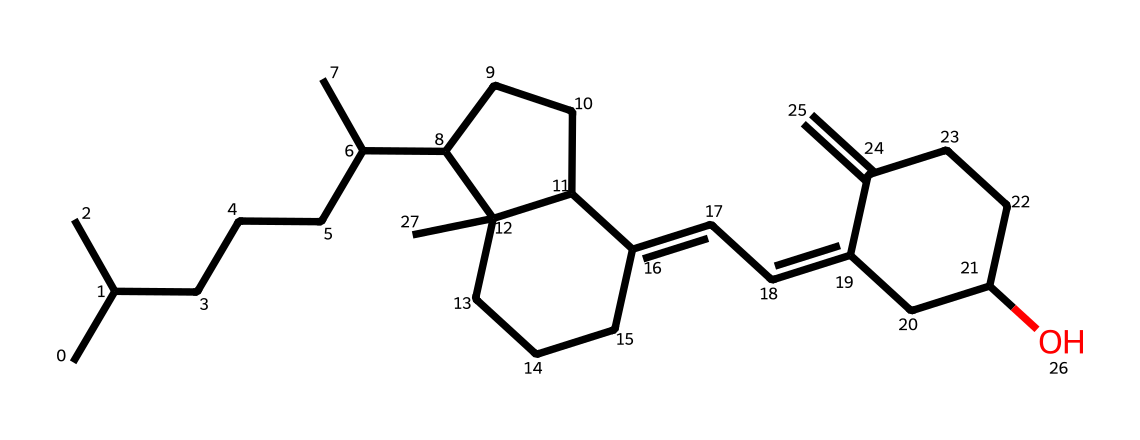What is the empirical formula of vitamin D3? By counting the numbers of carbon (C), hydrogen (H), and oxygen (O) atoms in the SMILES, we find there are 27 carbon atoms, 44 hydrogen atoms, and 1 oxygen atom. Therefore, the empirical formula is C27H44O.
Answer: C27H44O How many rings are present in the structure of vitamin D3? By examining the chemical structure, we can identify four rings. This is indicated by the cyclical arrangement of atoms present within the structure.
Answer: four What type of chemical is vitamin D3 classified as? Vitamin D3 is a type of sterol, a subgroup of steroids known to play a critical role in bone health. This classification is due to its multi-ring structure and lipid solubility.
Answer: sterol How does vitamin D3 affect calcium absorption? Vitamin D3 enhances the intestinal absorption of calcium, which is essential for maintaining healthy bone density and structure. This is a crucial function supported by its role as a hormone in the body.
Answer: enhances calcium absorption What functional group is present in vitamin D3? The hydroxyl group (-OH) is present in vitamin D3, which characterizes it as an alcohol. This functional group is significant for its biochemical activity.
Answer: hydroxyl group Which part of vitamin D3 is essential for bone health? The presence of the secosteroid structure in vitamin D3 is essential for bone health, as it allows the vitamin to interact with the vitamin D receptors, facilitating calcium metabolism.
Answer: secosteroid structure 